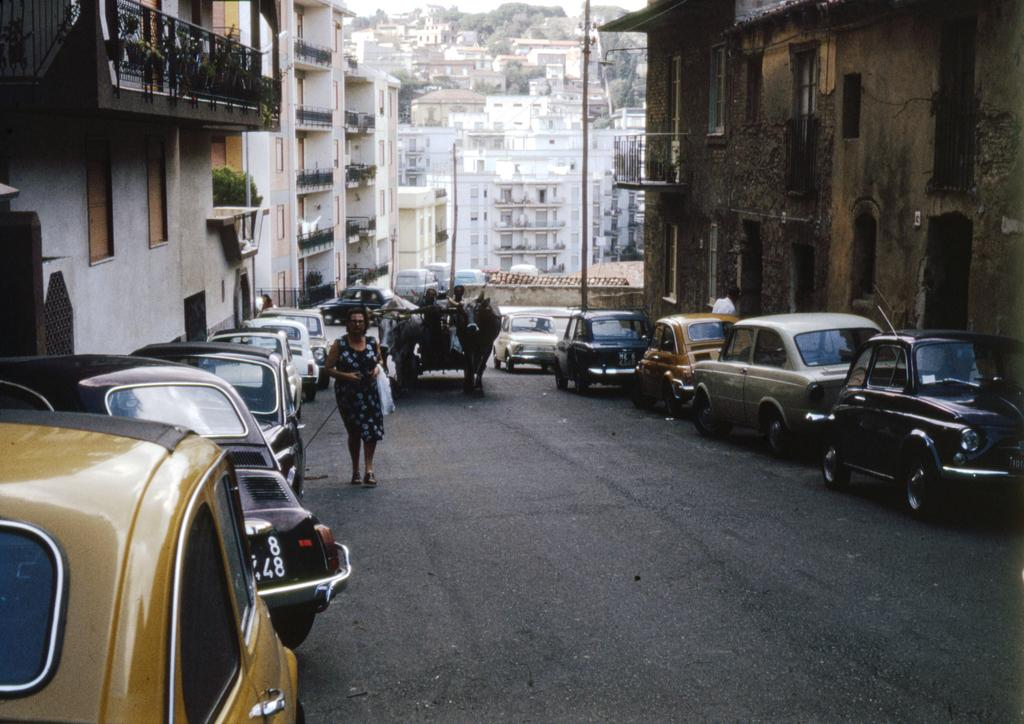What can be seen in the image related to transportation? There are cars parked in a queue in the image. What is the woman at the left side of the image doing? There is a woman walking at the left side of the image. What type of structures can be seen in the background of the image? There are buildings visible in the image. Can you see a ship in the image? No, there is no ship present in the image. How many chairs are visible in the image? There are no chairs visible in the image. 